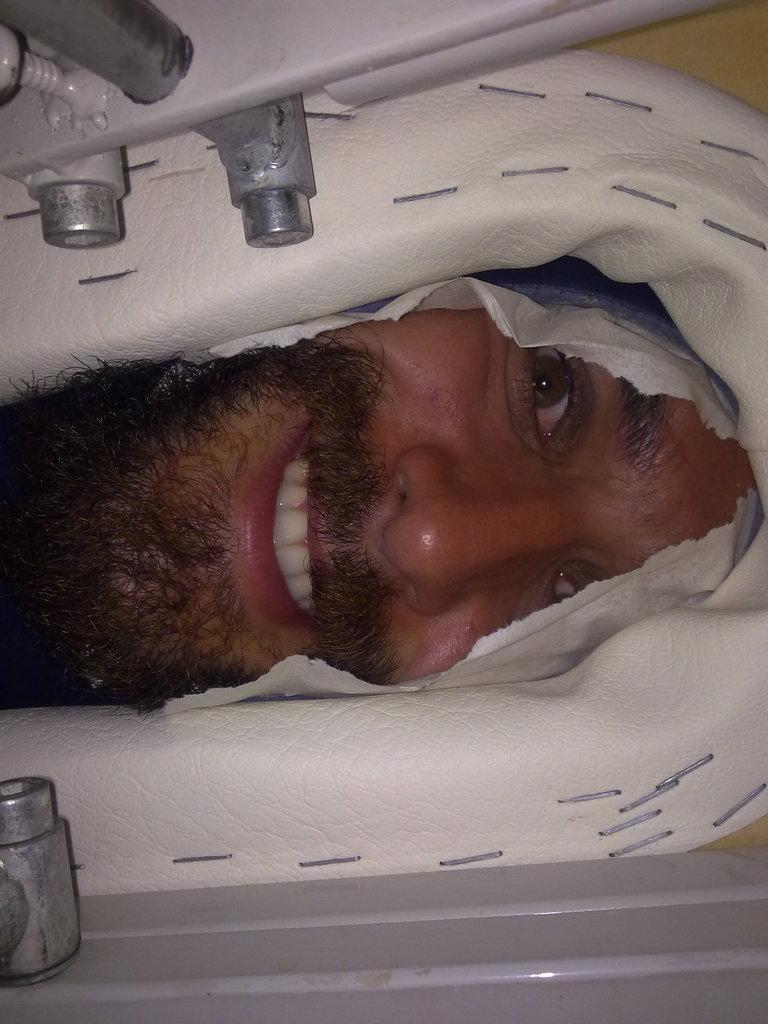In one or two sentences, can you explain what this image depicts? Here in this picture we can see a person peeking through a hole of something and we can see he is smiling. 